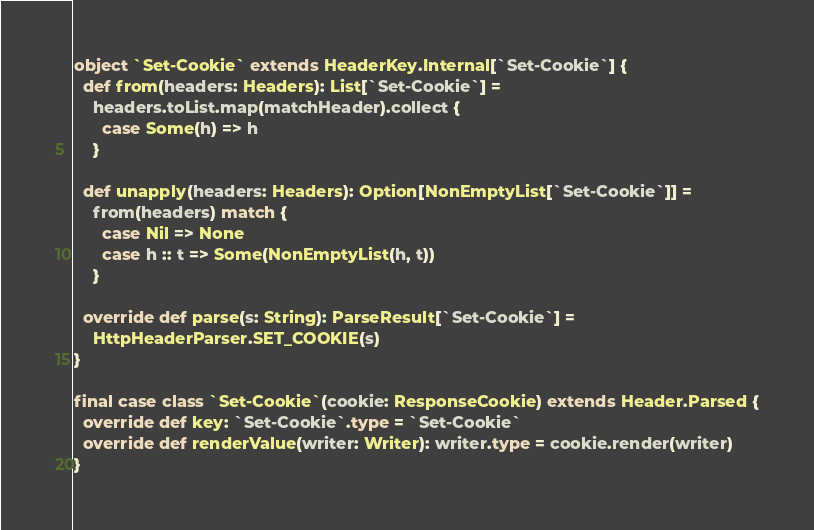<code> <loc_0><loc_0><loc_500><loc_500><_Scala_>object `Set-Cookie` extends HeaderKey.Internal[`Set-Cookie`] {
  def from(headers: Headers): List[`Set-Cookie`] =
    headers.toList.map(matchHeader).collect {
      case Some(h) => h
    }

  def unapply(headers: Headers): Option[NonEmptyList[`Set-Cookie`]] =
    from(headers) match {
      case Nil => None
      case h :: t => Some(NonEmptyList(h, t))
    }

  override def parse(s: String): ParseResult[`Set-Cookie`] =
    HttpHeaderParser.SET_COOKIE(s)
}

final case class `Set-Cookie`(cookie: ResponseCookie) extends Header.Parsed {
  override def key: `Set-Cookie`.type = `Set-Cookie`
  override def renderValue(writer: Writer): writer.type = cookie.render(writer)
}
</code> 